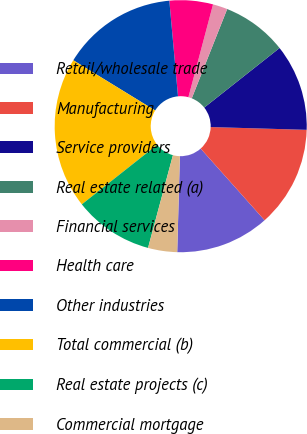Convert chart. <chart><loc_0><loc_0><loc_500><loc_500><pie_chart><fcel>Retail/wholesale trade<fcel>Manufacturing<fcel>Service providers<fcel>Real estate related (a)<fcel>Financial services<fcel>Health care<fcel>Other industries<fcel>Total commercial (b)<fcel>Real estate projects (c)<fcel>Commercial mortgage<nl><fcel>12.03%<fcel>12.95%<fcel>11.11%<fcel>8.34%<fcel>1.88%<fcel>5.57%<fcel>14.8%<fcel>19.41%<fcel>10.18%<fcel>3.73%<nl></chart> 